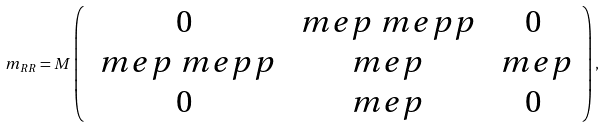Convert formula to latex. <formula><loc_0><loc_0><loc_500><loc_500>m _ { R R } = M \left ( \begin{array} { c c c } 0 & \ m e p \ m e p p & 0 \\ \ m e p \ m e p p & \ m e p & \ m e p \\ 0 & \ m e p & 0 \end{array} \right ) ,</formula> 